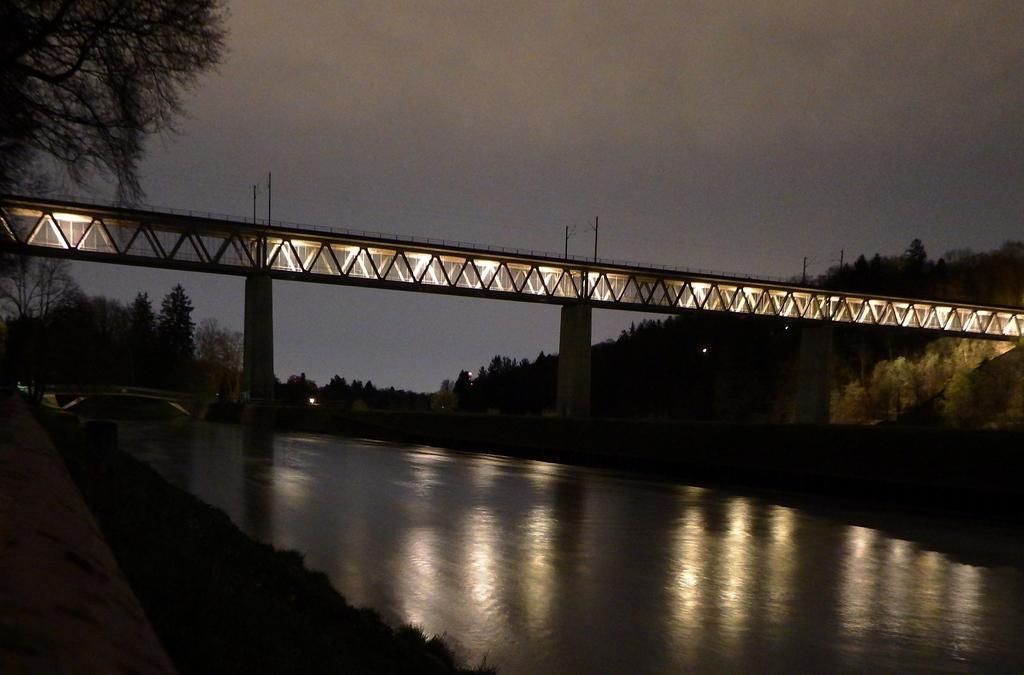Can you describe this image briefly? In the image we can see there is river and there are plants on the ground. There is a bridge and there are lot of trees. There is a clear sky and the image is in black and white colour. 